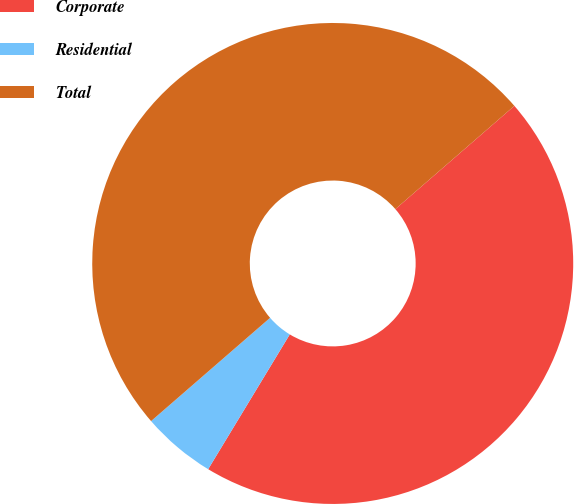Convert chart to OTSL. <chart><loc_0><loc_0><loc_500><loc_500><pie_chart><fcel>Corporate<fcel>Residential<fcel>Total<nl><fcel>45.04%<fcel>4.96%<fcel>50.0%<nl></chart> 